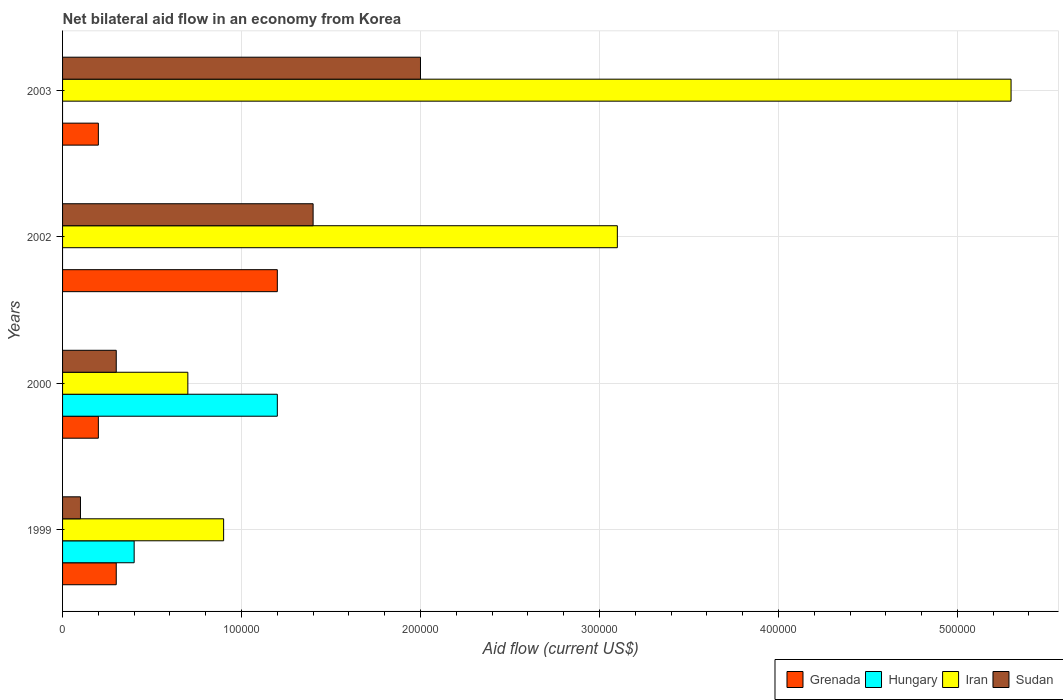How many different coloured bars are there?
Give a very brief answer. 4. In how many cases, is the number of bars for a given year not equal to the number of legend labels?
Provide a short and direct response. 2. Across all years, what is the minimum net bilateral aid flow in Grenada?
Provide a short and direct response. 2.00e+04. In which year was the net bilateral aid flow in Hungary maximum?
Your answer should be very brief. 2000. What is the total net bilateral aid flow in Sudan in the graph?
Your response must be concise. 3.80e+05. What is the difference between the net bilateral aid flow in Iran in 1999 and the net bilateral aid flow in Grenada in 2003?
Keep it short and to the point. 7.00e+04. What is the average net bilateral aid flow in Iran per year?
Your answer should be very brief. 2.50e+05. In how many years, is the net bilateral aid flow in Grenada greater than 300000 US$?
Make the answer very short. 0. What is the ratio of the net bilateral aid flow in Iran in 1999 to that in 2002?
Keep it short and to the point. 0.29. Is the net bilateral aid flow in Iran in 1999 less than that in 2002?
Offer a terse response. Yes. Is the difference between the net bilateral aid flow in Sudan in 1999 and 2002 greater than the difference between the net bilateral aid flow in Iran in 1999 and 2002?
Your answer should be very brief. Yes. What is the difference between the highest and the lowest net bilateral aid flow in Sudan?
Your answer should be very brief. 1.90e+05. Is the sum of the net bilateral aid flow in Iran in 2000 and 2003 greater than the maximum net bilateral aid flow in Hungary across all years?
Give a very brief answer. Yes. Is it the case that in every year, the sum of the net bilateral aid flow in Hungary and net bilateral aid flow in Grenada is greater than the sum of net bilateral aid flow in Sudan and net bilateral aid flow in Iran?
Make the answer very short. No. Is it the case that in every year, the sum of the net bilateral aid flow in Grenada and net bilateral aid flow in Hungary is greater than the net bilateral aid flow in Sudan?
Make the answer very short. No. How many bars are there?
Your answer should be very brief. 14. Are all the bars in the graph horizontal?
Offer a terse response. Yes. What is the difference between two consecutive major ticks on the X-axis?
Offer a terse response. 1.00e+05. Are the values on the major ticks of X-axis written in scientific E-notation?
Give a very brief answer. No. Does the graph contain any zero values?
Keep it short and to the point. Yes. Does the graph contain grids?
Offer a terse response. Yes. How many legend labels are there?
Keep it short and to the point. 4. How are the legend labels stacked?
Make the answer very short. Horizontal. What is the title of the graph?
Provide a short and direct response. Net bilateral aid flow in an economy from Korea. Does "Japan" appear as one of the legend labels in the graph?
Your response must be concise. No. What is the label or title of the X-axis?
Offer a terse response. Aid flow (current US$). What is the Aid flow (current US$) in Hungary in 1999?
Keep it short and to the point. 4.00e+04. What is the Aid flow (current US$) of Iran in 1999?
Offer a very short reply. 9.00e+04. What is the Aid flow (current US$) of Sudan in 1999?
Offer a very short reply. 10000. What is the Aid flow (current US$) of Grenada in 2000?
Offer a very short reply. 2.00e+04. What is the Aid flow (current US$) of Hungary in 2000?
Offer a very short reply. 1.20e+05. What is the Aid flow (current US$) in Iran in 2000?
Your answer should be very brief. 7.00e+04. What is the Aid flow (current US$) of Sudan in 2000?
Offer a very short reply. 3.00e+04. What is the Aid flow (current US$) of Iran in 2002?
Ensure brevity in your answer.  3.10e+05. What is the Aid flow (current US$) in Iran in 2003?
Provide a succinct answer. 5.30e+05. Across all years, what is the maximum Aid flow (current US$) in Hungary?
Your response must be concise. 1.20e+05. Across all years, what is the maximum Aid flow (current US$) of Iran?
Offer a terse response. 5.30e+05. Across all years, what is the minimum Aid flow (current US$) of Sudan?
Ensure brevity in your answer.  10000. What is the total Aid flow (current US$) of Sudan in the graph?
Provide a short and direct response. 3.80e+05. What is the difference between the Aid flow (current US$) in Hungary in 1999 and that in 2000?
Your answer should be very brief. -8.00e+04. What is the difference between the Aid flow (current US$) in Grenada in 1999 and that in 2002?
Ensure brevity in your answer.  -9.00e+04. What is the difference between the Aid flow (current US$) in Iran in 1999 and that in 2002?
Your response must be concise. -2.20e+05. What is the difference between the Aid flow (current US$) of Sudan in 1999 and that in 2002?
Offer a terse response. -1.30e+05. What is the difference between the Aid flow (current US$) of Grenada in 1999 and that in 2003?
Ensure brevity in your answer.  10000. What is the difference between the Aid flow (current US$) of Iran in 1999 and that in 2003?
Your answer should be compact. -4.40e+05. What is the difference between the Aid flow (current US$) of Sudan in 2000 and that in 2002?
Offer a terse response. -1.10e+05. What is the difference between the Aid flow (current US$) of Grenada in 2000 and that in 2003?
Ensure brevity in your answer.  0. What is the difference between the Aid flow (current US$) in Iran in 2000 and that in 2003?
Offer a very short reply. -4.60e+05. What is the difference between the Aid flow (current US$) in Grenada in 2002 and that in 2003?
Provide a short and direct response. 1.00e+05. What is the difference between the Aid flow (current US$) of Iran in 2002 and that in 2003?
Provide a short and direct response. -2.20e+05. What is the difference between the Aid flow (current US$) in Hungary in 1999 and the Aid flow (current US$) in Iran in 2000?
Your answer should be very brief. -3.00e+04. What is the difference between the Aid flow (current US$) of Iran in 1999 and the Aid flow (current US$) of Sudan in 2000?
Ensure brevity in your answer.  6.00e+04. What is the difference between the Aid flow (current US$) in Grenada in 1999 and the Aid flow (current US$) in Iran in 2002?
Your response must be concise. -2.80e+05. What is the difference between the Aid flow (current US$) in Grenada in 1999 and the Aid flow (current US$) in Sudan in 2002?
Your response must be concise. -1.10e+05. What is the difference between the Aid flow (current US$) of Grenada in 1999 and the Aid flow (current US$) of Iran in 2003?
Ensure brevity in your answer.  -5.00e+05. What is the difference between the Aid flow (current US$) in Hungary in 1999 and the Aid flow (current US$) in Iran in 2003?
Give a very brief answer. -4.90e+05. What is the difference between the Aid flow (current US$) in Grenada in 2000 and the Aid flow (current US$) in Iran in 2002?
Your answer should be compact. -2.90e+05. What is the difference between the Aid flow (current US$) in Grenada in 2000 and the Aid flow (current US$) in Sudan in 2002?
Ensure brevity in your answer.  -1.20e+05. What is the difference between the Aid flow (current US$) in Hungary in 2000 and the Aid flow (current US$) in Sudan in 2002?
Ensure brevity in your answer.  -2.00e+04. What is the difference between the Aid flow (current US$) in Grenada in 2000 and the Aid flow (current US$) in Iran in 2003?
Keep it short and to the point. -5.10e+05. What is the difference between the Aid flow (current US$) in Hungary in 2000 and the Aid flow (current US$) in Iran in 2003?
Provide a succinct answer. -4.10e+05. What is the difference between the Aid flow (current US$) of Grenada in 2002 and the Aid flow (current US$) of Iran in 2003?
Make the answer very short. -4.10e+05. What is the difference between the Aid flow (current US$) in Iran in 2002 and the Aid flow (current US$) in Sudan in 2003?
Provide a short and direct response. 1.10e+05. What is the average Aid flow (current US$) of Grenada per year?
Make the answer very short. 4.75e+04. What is the average Aid flow (current US$) in Hungary per year?
Your answer should be compact. 4.00e+04. What is the average Aid flow (current US$) of Sudan per year?
Give a very brief answer. 9.50e+04. In the year 1999, what is the difference between the Aid flow (current US$) of Grenada and Aid flow (current US$) of Iran?
Keep it short and to the point. -6.00e+04. In the year 1999, what is the difference between the Aid flow (current US$) of Grenada and Aid flow (current US$) of Sudan?
Make the answer very short. 2.00e+04. In the year 1999, what is the difference between the Aid flow (current US$) of Hungary and Aid flow (current US$) of Iran?
Ensure brevity in your answer.  -5.00e+04. In the year 1999, what is the difference between the Aid flow (current US$) in Hungary and Aid flow (current US$) in Sudan?
Make the answer very short. 3.00e+04. In the year 1999, what is the difference between the Aid flow (current US$) of Iran and Aid flow (current US$) of Sudan?
Your response must be concise. 8.00e+04. In the year 2000, what is the difference between the Aid flow (current US$) in Grenada and Aid flow (current US$) in Hungary?
Your answer should be compact. -1.00e+05. In the year 2000, what is the difference between the Aid flow (current US$) in Grenada and Aid flow (current US$) in Iran?
Provide a short and direct response. -5.00e+04. In the year 2000, what is the difference between the Aid flow (current US$) in Grenada and Aid flow (current US$) in Sudan?
Offer a terse response. -10000. In the year 2000, what is the difference between the Aid flow (current US$) of Hungary and Aid flow (current US$) of Sudan?
Your response must be concise. 9.00e+04. In the year 2000, what is the difference between the Aid flow (current US$) in Iran and Aid flow (current US$) in Sudan?
Offer a very short reply. 4.00e+04. In the year 2002, what is the difference between the Aid flow (current US$) in Grenada and Aid flow (current US$) in Iran?
Offer a terse response. -1.90e+05. In the year 2002, what is the difference between the Aid flow (current US$) of Grenada and Aid flow (current US$) of Sudan?
Provide a succinct answer. -2.00e+04. In the year 2002, what is the difference between the Aid flow (current US$) of Iran and Aid flow (current US$) of Sudan?
Your answer should be very brief. 1.70e+05. In the year 2003, what is the difference between the Aid flow (current US$) in Grenada and Aid flow (current US$) in Iran?
Provide a succinct answer. -5.10e+05. In the year 2003, what is the difference between the Aid flow (current US$) of Grenada and Aid flow (current US$) of Sudan?
Your answer should be very brief. -1.80e+05. In the year 2003, what is the difference between the Aid flow (current US$) of Iran and Aid flow (current US$) of Sudan?
Your response must be concise. 3.30e+05. What is the ratio of the Aid flow (current US$) in Grenada in 1999 to that in 2000?
Your answer should be compact. 1.5. What is the ratio of the Aid flow (current US$) in Hungary in 1999 to that in 2000?
Provide a short and direct response. 0.33. What is the ratio of the Aid flow (current US$) of Sudan in 1999 to that in 2000?
Provide a short and direct response. 0.33. What is the ratio of the Aid flow (current US$) of Grenada in 1999 to that in 2002?
Your answer should be very brief. 0.25. What is the ratio of the Aid flow (current US$) in Iran in 1999 to that in 2002?
Give a very brief answer. 0.29. What is the ratio of the Aid flow (current US$) in Sudan in 1999 to that in 2002?
Your answer should be compact. 0.07. What is the ratio of the Aid flow (current US$) in Iran in 1999 to that in 2003?
Provide a short and direct response. 0.17. What is the ratio of the Aid flow (current US$) of Sudan in 1999 to that in 2003?
Make the answer very short. 0.05. What is the ratio of the Aid flow (current US$) of Iran in 2000 to that in 2002?
Keep it short and to the point. 0.23. What is the ratio of the Aid flow (current US$) of Sudan in 2000 to that in 2002?
Your answer should be very brief. 0.21. What is the ratio of the Aid flow (current US$) in Iran in 2000 to that in 2003?
Make the answer very short. 0.13. What is the ratio of the Aid flow (current US$) in Grenada in 2002 to that in 2003?
Your response must be concise. 6. What is the ratio of the Aid flow (current US$) of Iran in 2002 to that in 2003?
Make the answer very short. 0.58. What is the difference between the highest and the second highest Aid flow (current US$) in Iran?
Offer a terse response. 2.20e+05. What is the difference between the highest and the lowest Aid flow (current US$) of Iran?
Provide a succinct answer. 4.60e+05. What is the difference between the highest and the lowest Aid flow (current US$) of Sudan?
Provide a succinct answer. 1.90e+05. 